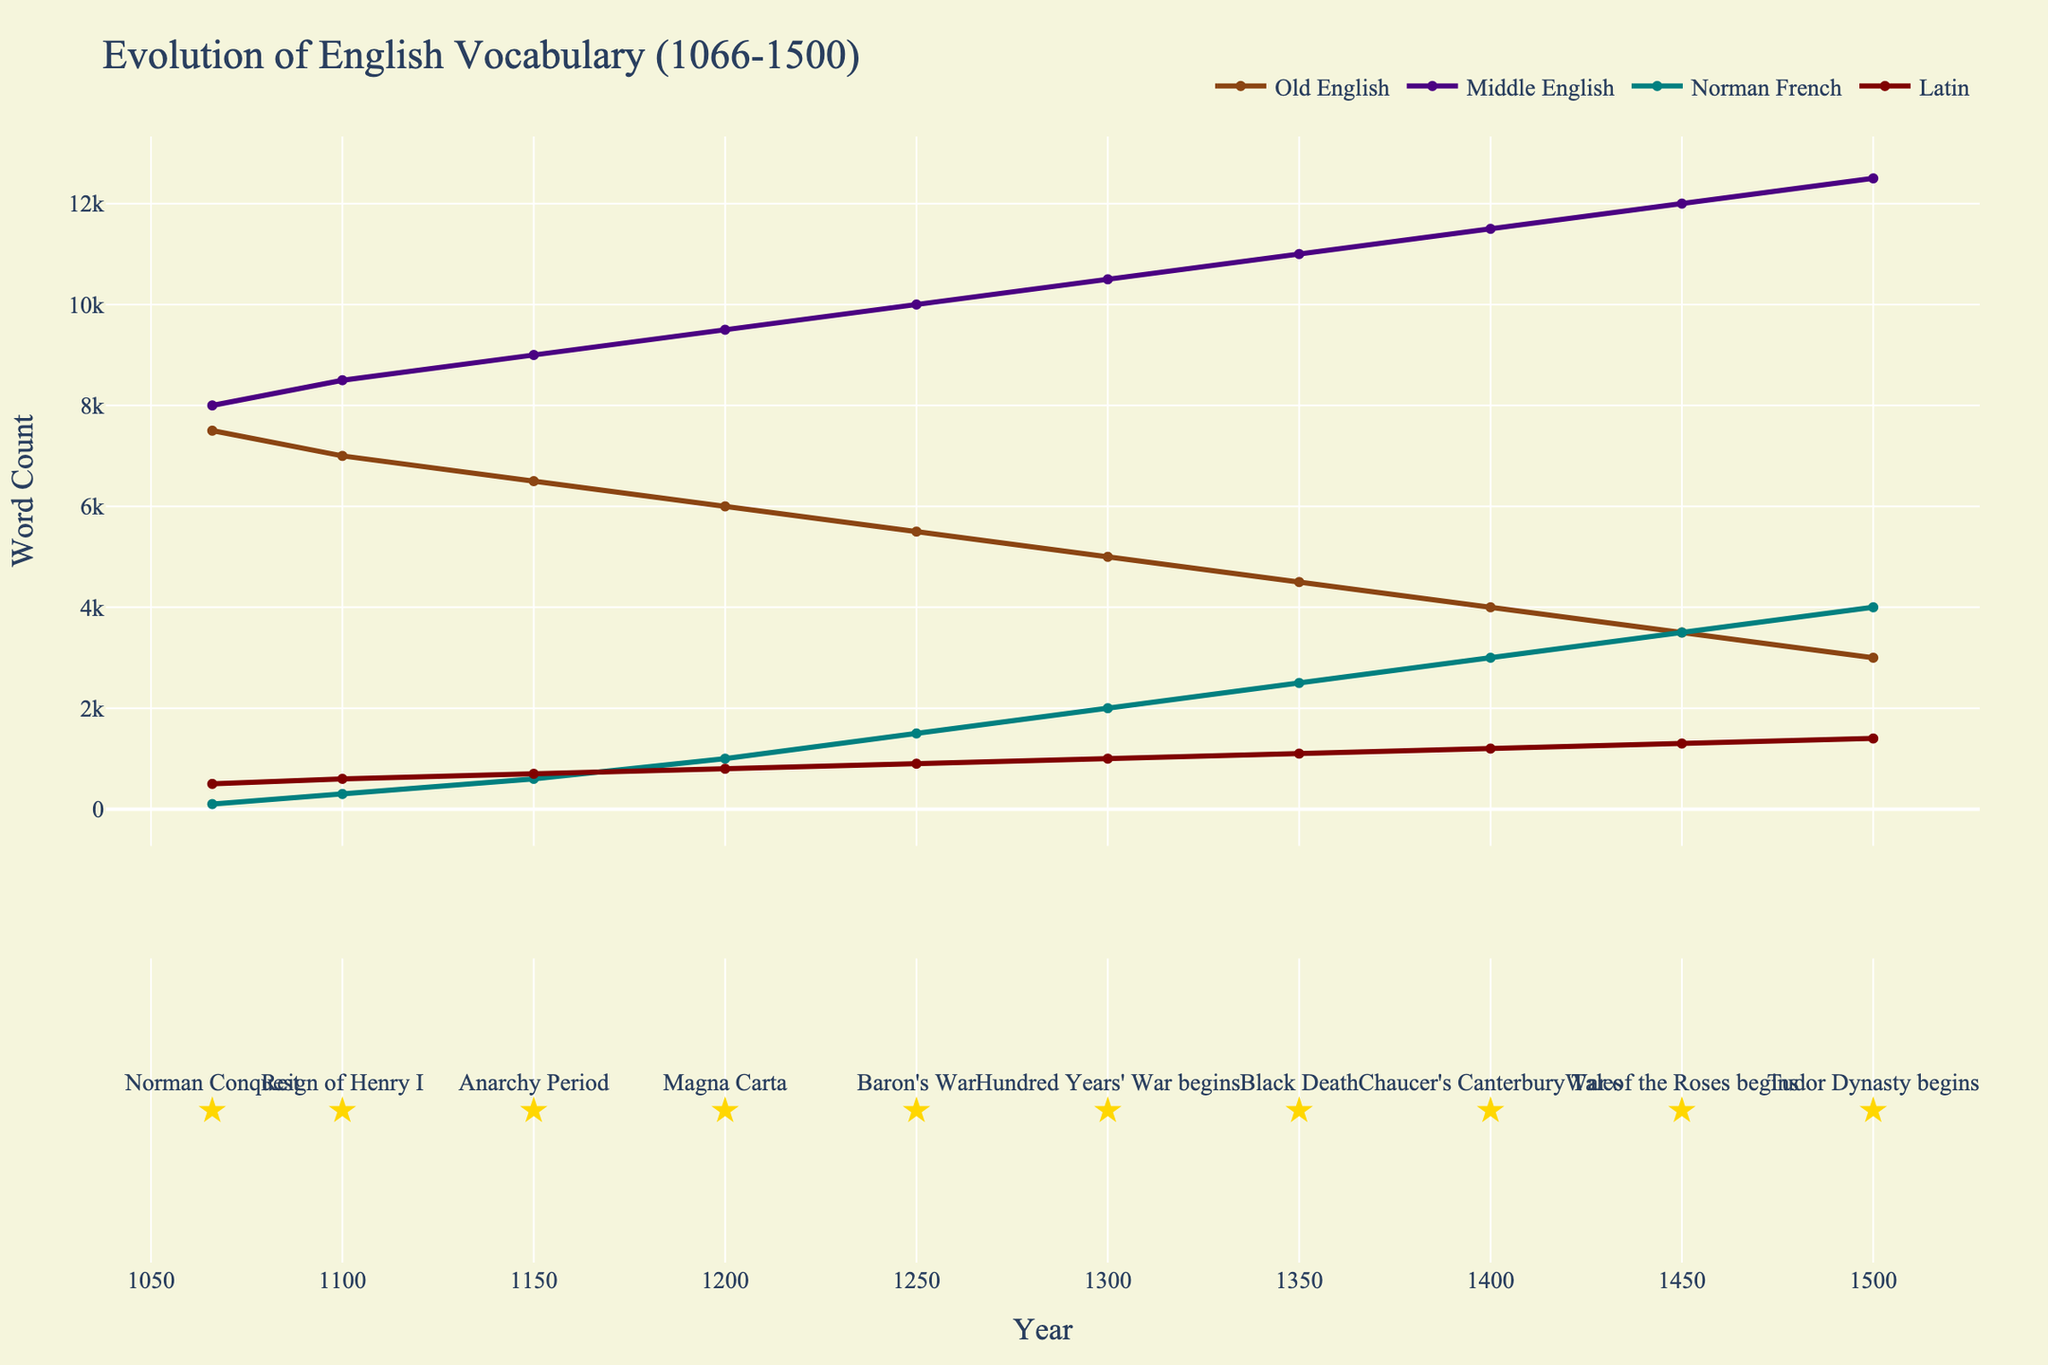How did the number of Old English words change from 1066 to 1500? In the figure, the brown line representing Old English words shows a downward trend from 7500 words in 1066 to 3000 words in 1500.
Answer: The number of Old English words decreased by 4500 Which year saw the highest increase in Norman French Loanwords compared to the previous period? By observing the green line representing Norman French Loanwords, the largest increase occurs between 1250 to 1300, going from 1500 to 2000, an increase of 500 words.
Answer: Between 1250 and 1300 Compare the total number of Latin Loanwords and Norman French Loanwords in the year 1400. Which is higher and by how much? In 1400, Latin Loanwords reached 1200 and Norman French Loanwords were at 3000. The difference is 3000 - 1200 = 1800.
Answer: Norman French Loanwords by 1800 From 1066 to 1350, which category of words had the least change in count? Analyzing the starting and ending points of each line from 1066 to 1350, Old English decreased by 3000 (from 7500 to 4500), Middle English increased by 3000 (8000 to 11000), Latin increased by 600 (500 to 1100), and Norman French increased by 2400 (100 to 2500). Latin had the least change at 600.
Answer: Latin Loanwords Which period saw the most significant reduction in Old English words? According to the brown line representing Old English words, the most significant drop from 5500 to 5000 happens between 1250 to 1300, a loss of 500 words.
Answer: Between 1250 and 1300 What is the ratio of Middle English words to Old English words in 1500? In 1500, there are 12500 Middle English words and 3000 Old English words. The ratio is 12500 / 3000, simplifying to approximately 4.17.
Answer: 4.17 Between which two historical events did Latin Loanwords see the most significant growth? From the text labels and changes in the red line representing Latin Loanwords, the most significant rise is between the Black Death (1350) and Chaucer's Canterbury Tales (1400), increasing from 1100 to 1200.
Answer: Between Black Death and Chaucer's Canterbury Tales What was the difference in the number of Middle English words before and after the Magna Carta event? Before Magna Carta (1200), there were 9500 Middle English words. After Magna Carta (1250), there were 10000 words. The difference is 10000 - 9500 = 500.
Answer: 500 In which year did Middle English words surpass 10000 for the first time, and what historical event corresponds to that year? Looking at the purple line for Middle English words, it first surpasses 10000 in the year 1250, which corresponds to the Baron's War.
Answer: 1250, Baron's War By how much did Latin Loanwords grow from the Norman Conquest to the start of the War of the Roses? In 1066 (Norman Conquest), there were 500 Latin Loanwords. By 1450 (War of the Roses), there were 1300. The growth is 1300 - 500 = 800.
Answer: 800 